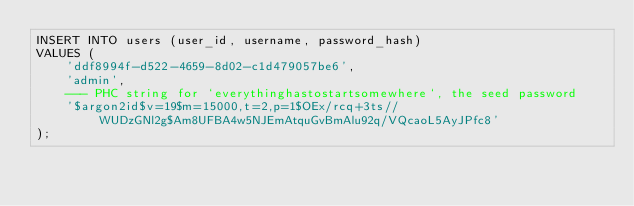Convert code to text. <code><loc_0><loc_0><loc_500><loc_500><_SQL_>INSERT INTO users (user_id, username, password_hash)
VALUES (
    'ddf8994f-d522-4659-8d02-c1d479057be6',
    'admin',
    --- PHC string for `everythinghastostartsomewhere`, the seed password
    '$argon2id$v=19$m=15000,t=2,p=1$OEx/rcq+3ts//WUDzGNl2g$Am8UFBA4w5NJEmAtquGvBmAlu92q/VQcaoL5AyJPfc8'
);
</code> 